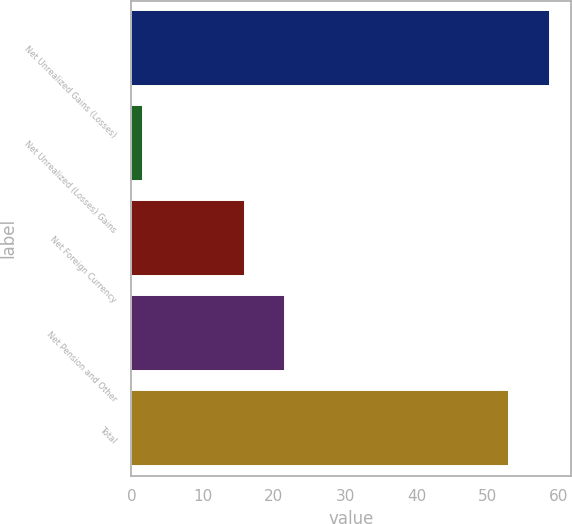Convert chart. <chart><loc_0><loc_0><loc_500><loc_500><bar_chart><fcel>Net Unrealized Gains (Losses)<fcel>Net Unrealized (Losses) Gains<fcel>Net Foreign Currency<fcel>Net Pension and Other<fcel>Total<nl><fcel>58.69<fcel>1.7<fcel>15.9<fcel>21.59<fcel>53<nl></chart> 